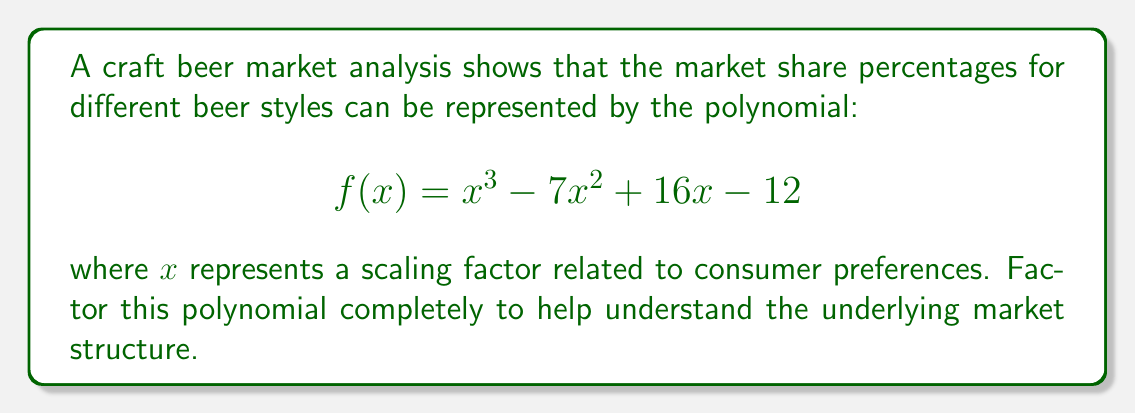Can you answer this question? To factor this polynomial, we'll follow these steps:

1) First, let's check if there are any rational roots using the rational root theorem. The possible rational roots are the factors of the constant term: $\pm 1, \pm 2, \pm 3, \pm 4, \pm 6, \pm 12$

2) Testing these values, we find that $f(2) = 0$. So $(x-2)$ is a factor.

3) We can now use polynomial long division to divide $f(x)$ by $(x-2)$:

   $$\frac{x^3 - 7x^2 + 16x - 12}{x - 2} = x^2 - 5x + 6$$

4) So now we have: $f(x) = (x-2)(x^2 - 5x + 6)$

5) The quadratic factor $x^2 - 5x + 6$ can be factored further:
   
   $$x^2 - 5x + 6 = (x-2)(x-3)$$

6) Therefore, the complete factorization is:

   $$f(x) = (x-2)(x-2)(x-3)$$

This factorization reveals that the market structure has three key components, two identical factors $(x-2)$ and one factor $(x-3)$, which could represent different segments or trends in the craft beer market.
Answer: $$f(x) = (x-2)^2(x-3)$$ 